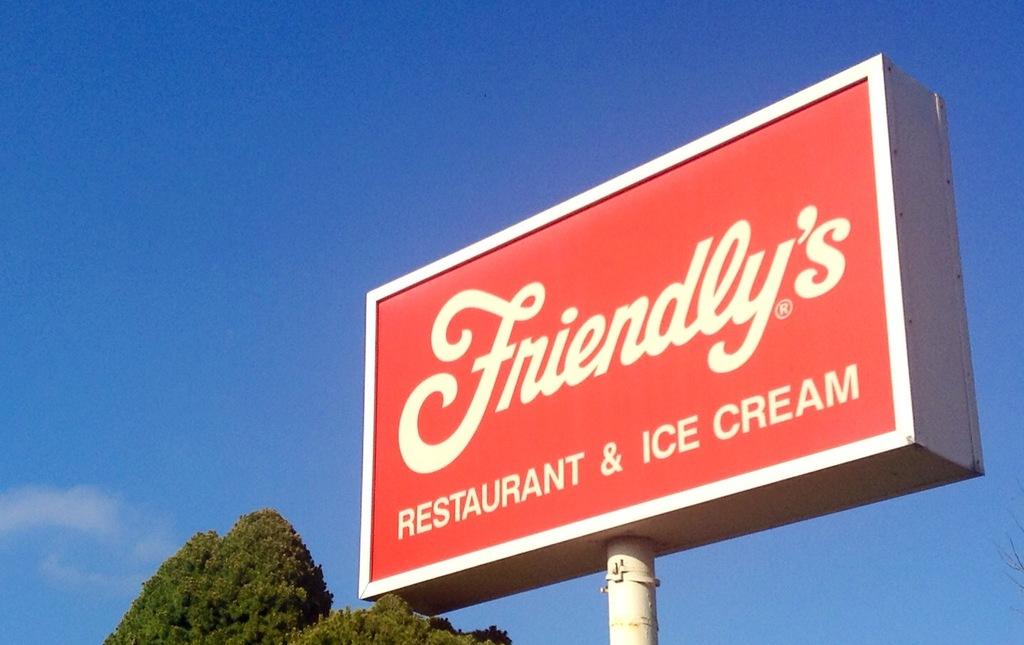What is the name of the restaurant on the sign?
Offer a very short reply. Friendly's. The sign says restaurant & what?
Ensure brevity in your answer.  Ice cream. 